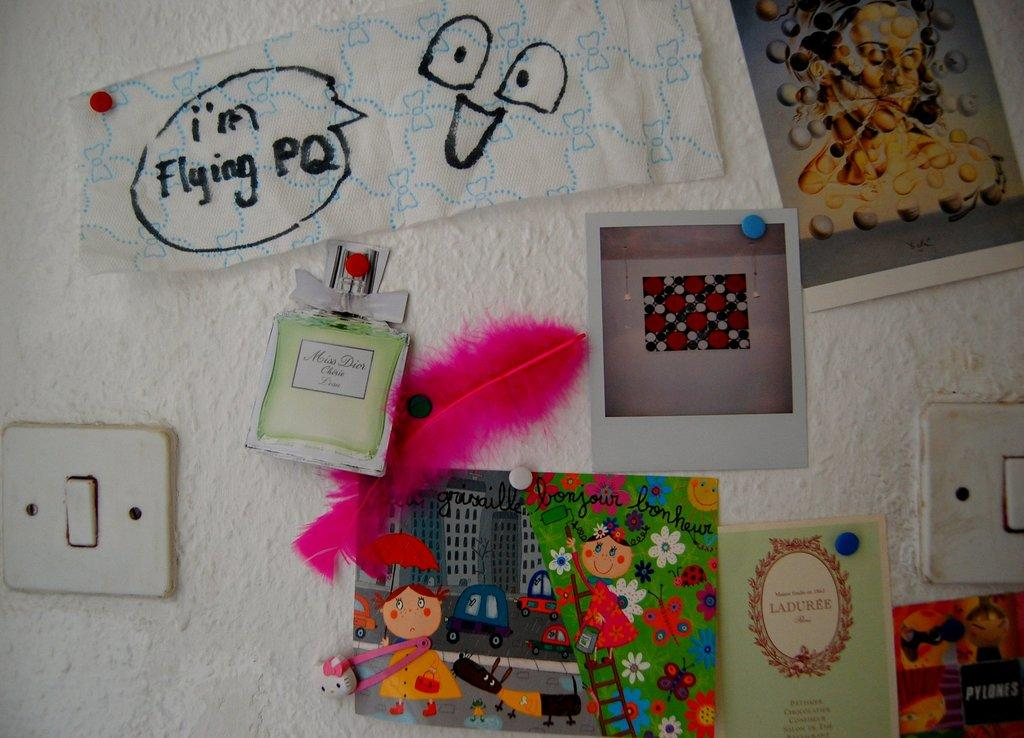Provide a one-sentence caption for the provided image. A wall filled with pictures and cut outs of Miss Dior perfume. 